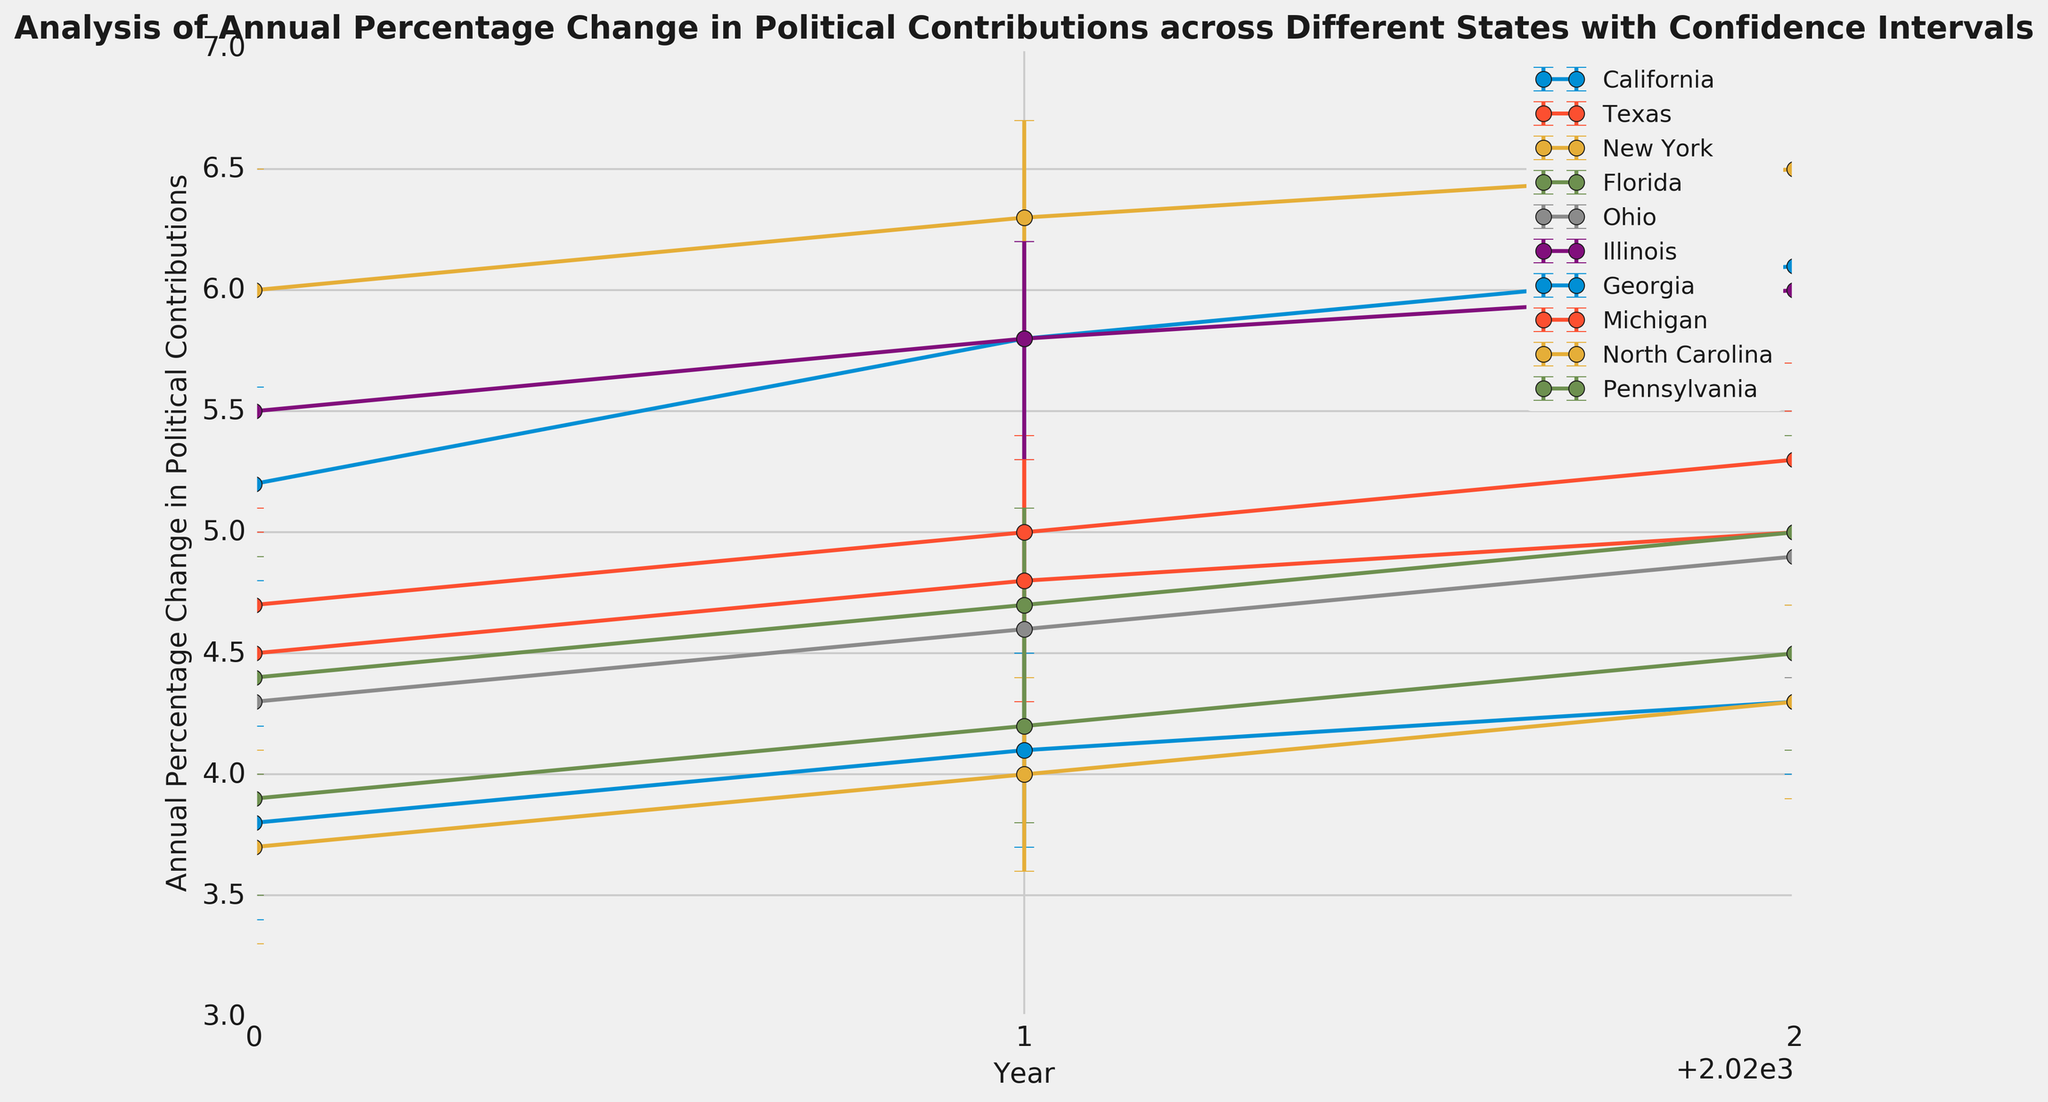Which state had the highest annual percentage change in political contributions in 2022? Look at the 2022 data points on the graph. New York shows the highest data point for that year.
Answer: New York What is the difference in the annual percentage change between Texas and California in 2021? Locate the values for Texas and California in 2021 on the graph. The difference is 5.8 (California) - 5.0 (Texas) = 0.8.
Answer: 0.8 Which states had overlapping confidence intervals in 2020? Observe the error bars for each state in 2020. California, Texas, New York, and Illinois show overlapping ranges, while Florida, Ohio, Georgia, Michigan, North Carolina, and Pennsylvania have distinct intervals.
Answer: California, Texas, New York, Illinois How did the annual percentage change for Florida compare visually between 2020 and 2022? Compare the height of the data points for Florida in 2020 and 2022. The 2022 data point is higher, showing an increase from 3.9% to 4.5%.
Answer: Increased What is the average annual percentage change in political contributions for Ohio across the provided years? Sum the annual percentage changes for Ohio for 2020, 2021, and 2022, then divide by the number of years: (4.3 + 4.6 + 4.9)/3 = 13.8/3.
Answer: 4.6 Which state had the smallest annual percentage change in political contributions in 2020? Identify the lowest data point in 2020. North Carolina shows the smallest value at 3.7%.
Answer: North Carolina Did Illinois see a consistent increase in the annual percentage change from 2020 to 2022? Observe the trend of Illinois' data points across the years. Each year shows an increase from the previous year.
Answer: Yes Which state showed the largest increase in the annual percentage change between 2020 and 2022? Calculate the difference for each state between 2020 and 2022. New York increased from 6.0% to 6.5%, an increase of 0.5%.
Answer: New York Compare the confidence interval width for California between 2020 and 2021. Measure the length of the error bars visually for both years. California's confidence interval widens from 0.8 in 2020 to 0.9 in 2021.
Answer: Wider 